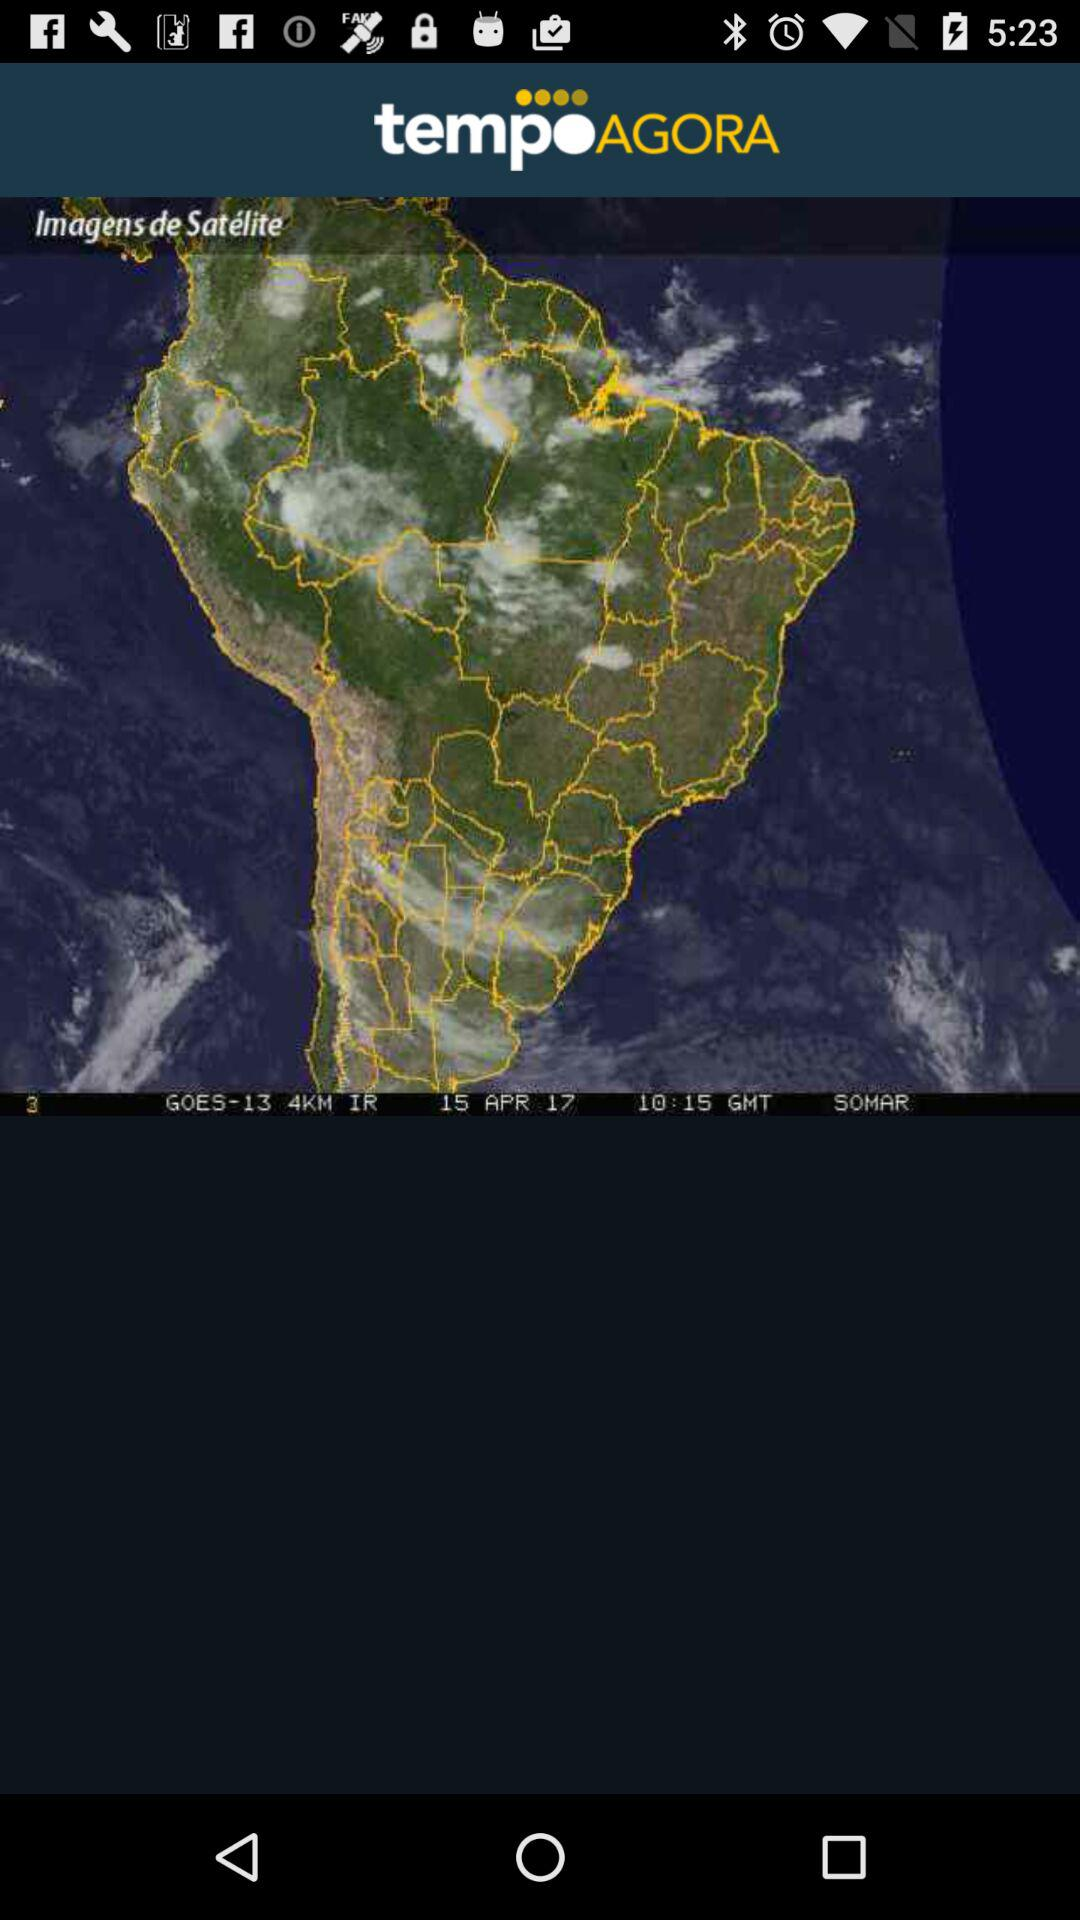What is the application name? The application name is "tempoAGORA". 